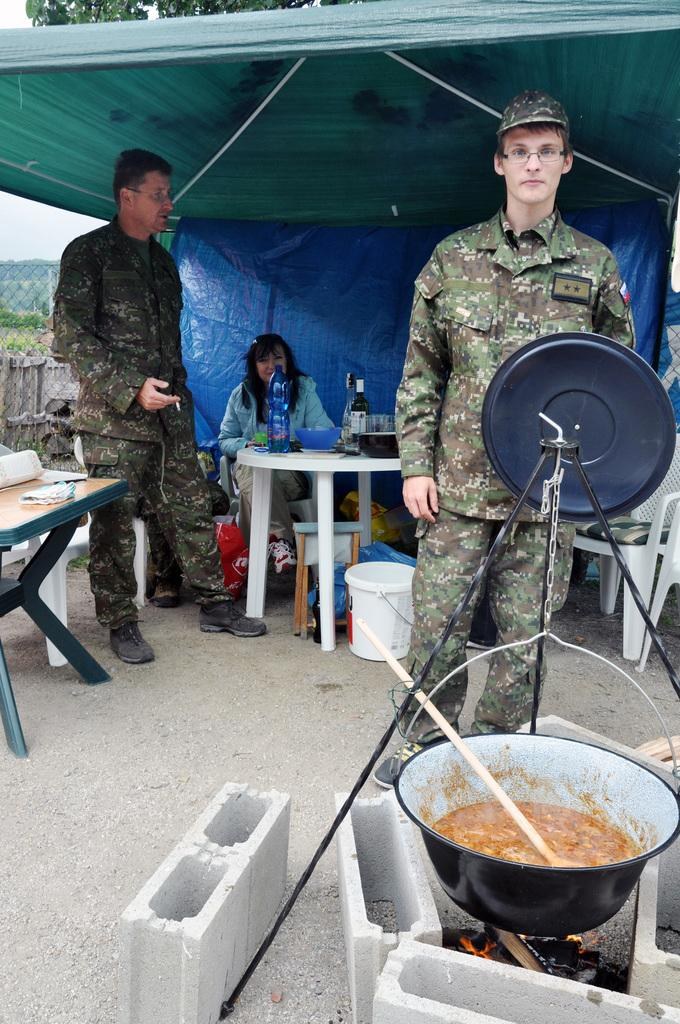How many people are present in the image? There are two men and one woman, making a total of three people in the image. What are the men doing in the image? The men are standing in the image. What is the woman doing in the image? The woman is seated on a chair in the image. What objects can be seen on the table in the image? There are bottles on a table in the image. What is happening with the food in the image? The food is on a stove in the image. What type of haircut is the expert giving to the woman in the image? There is no haircut or expert present in the image. What kind of fuel is being used to cook the food in the image? The type of fuel used to cook the food is not visible in the image. 